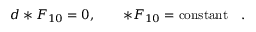Convert formula to latex. <formula><loc_0><loc_0><loc_500><loc_500>d * F _ { 1 0 } = 0 , \quad * F _ { 1 0 } = c o n s t a n t \quad .</formula> 